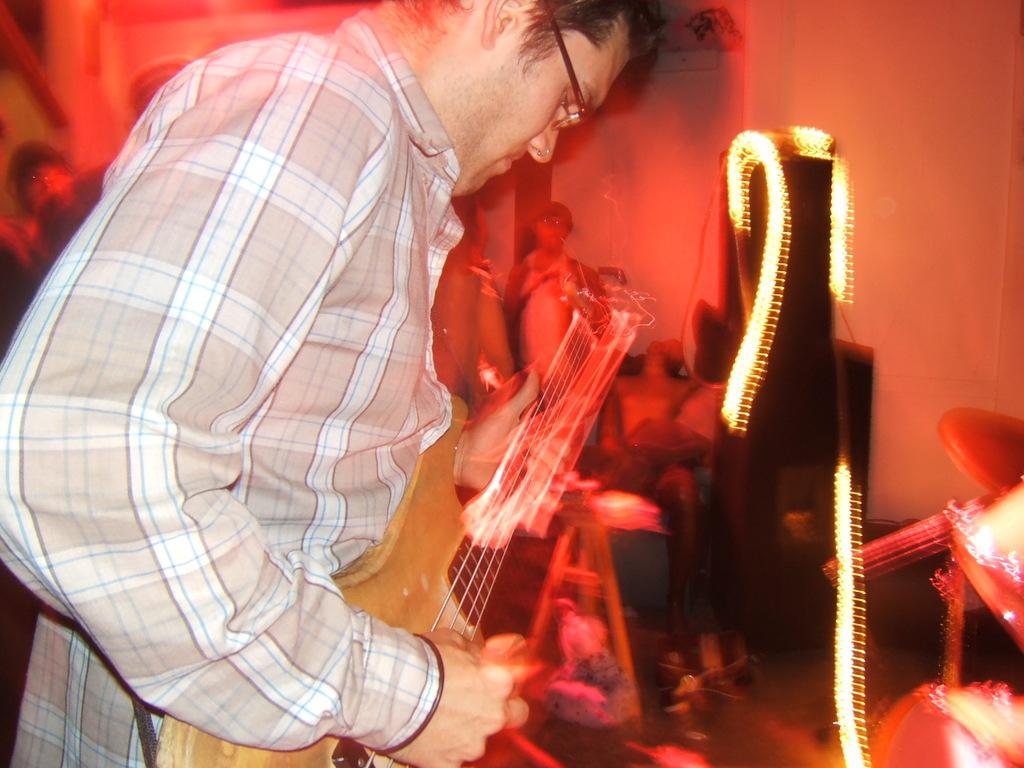Could you give a brief overview of what you see in this image? Here in this picture we can see a man with checked shirt is playing a guitar. he is having spectacles. In front of him there are some lightnings. 